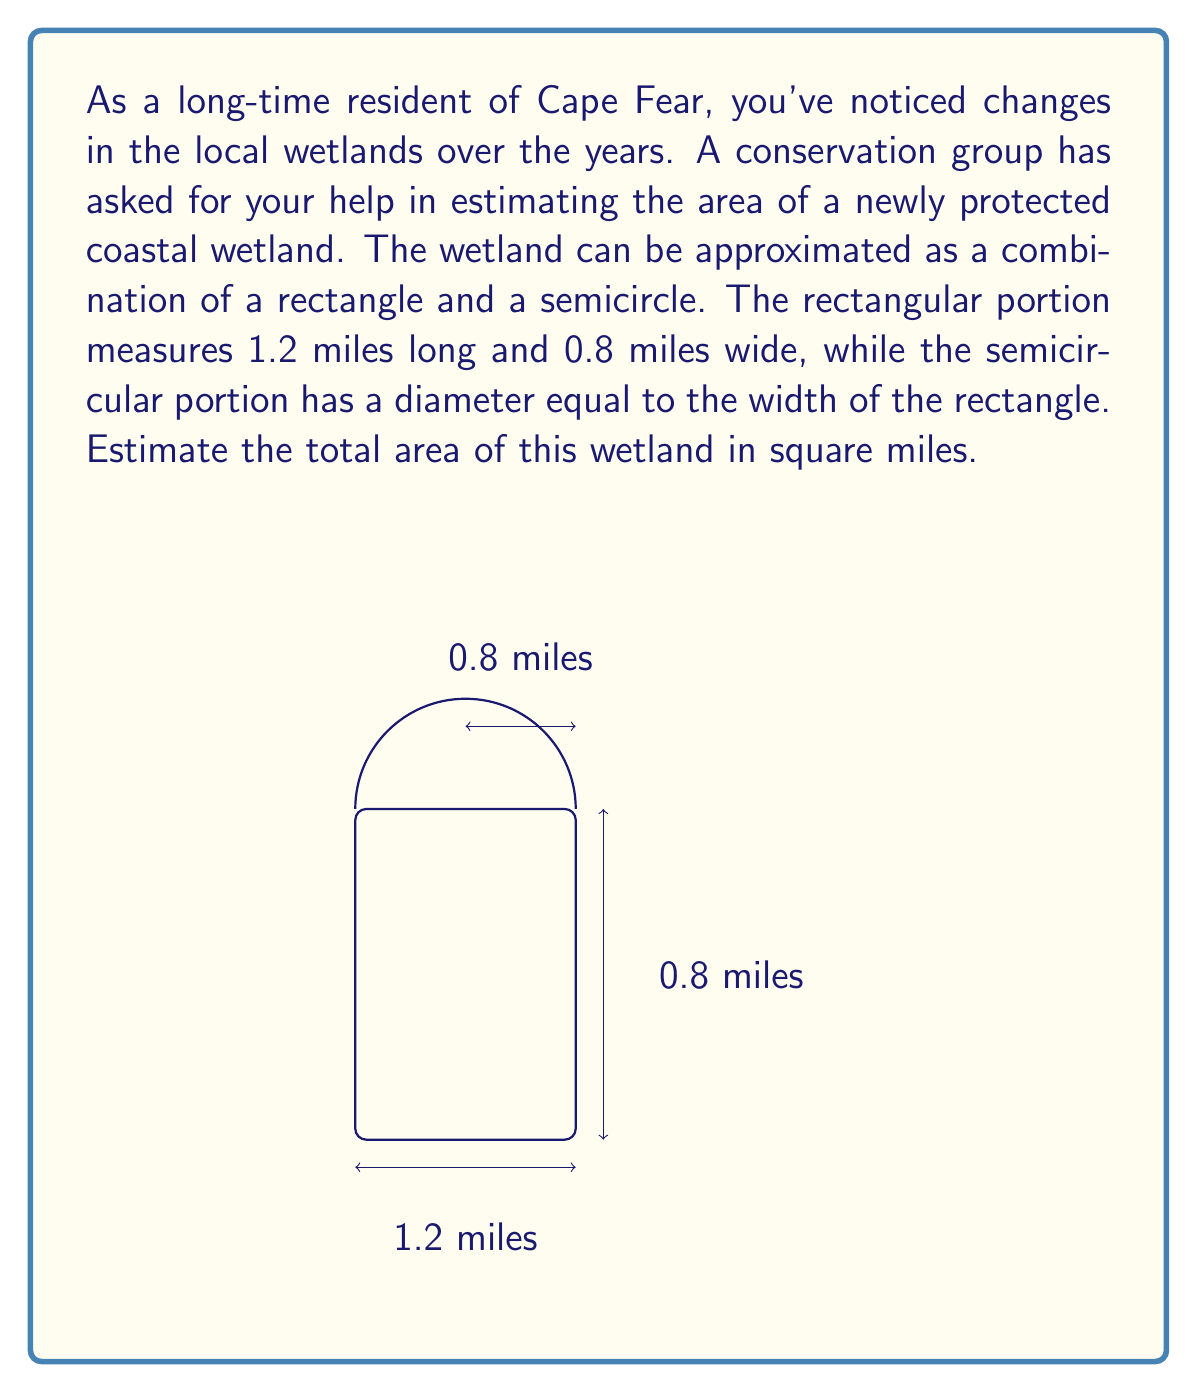Help me with this question. Let's approach this step-by-step:

1) First, we need to calculate the area of the rectangular portion:
   $$A_{rectangle} = length \times width = 1.2 \text{ miles} \times 0.8 \text{ miles} = 0.96 \text{ square miles}$$

2) Next, we'll calculate the area of the semicircular portion:
   - The diameter of the semicircle is equal to the width of the rectangle, which is 0.8 miles.
   - The radius is therefore 0.4 miles.
   - The area of a full circle is $\pi r^2$, so the area of a semicircle is $\frac{1}{2}\pi r^2$

   $$A_{semicircle} = \frac{1}{2}\pi r^2 = \frac{1}{2} \times \pi \times (0.4)^2 \approx 0.2513 \text{ square miles}$$

3) The total area is the sum of these two parts:
   $$A_{total} = A_{rectangle} + A_{semicircle} = 0.96 + 0.2513 = 1.2113 \text{ square miles}$$

4) Since we're estimating, we can round this to 1.21 square miles.

This method of using basic geometric shapes to estimate irregular areas is a common technique in environmental science and land management, allowing for quick approximations without the need for complex measurements.
Answer: The estimated area of the coastal wetland is approximately 1.21 square miles. 